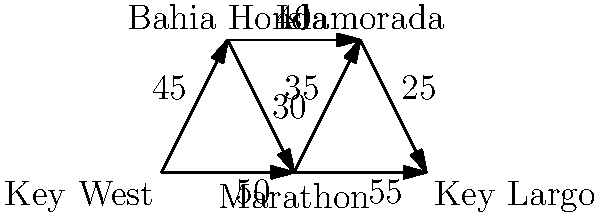As a new resident in the Florida Keys, you want to explore the popular tourist attractions. The graph shows the distances (in miles) between key locations. What is the shortest path from Key West to Key Largo, and what is its total distance? To find the shortest path from Key West to Key Largo, we'll use Dijkstra's algorithm:

1. Start at Key West (source node).
2. Initialize distances: Key West (0), others (infinity).
3. Visit unvisited node with smallest distance (Key West).
4. Update distances to neighbors:
   - Bahia Honda: 45 miles
   - Marathon: 50 miles
5. Visit Marathon (50 < 45).
6. Update distances:
   - Bahia Honda: min(45, 50 + 30) = 45 miles
   - Islamorada: 50 + 35 = 85 miles
   - Key Largo: 50 + 55 = 105 miles
7. Visit Bahia Honda (45 < 85).
8. Update distances:
   - Islamorada: min(85, 45 + 40) = 85 miles
9. Visit Islamorada (85 < 105).
10. Update distances:
    - Key Largo: min(105, 85 + 25) = 85 + 25 = 110 miles

The shortest path is Key West → Marathon → Islamorada → Key Largo.
Total distance: 50 + 35 + 25 = 110 miles.
Answer: Key West → Marathon → Islamorada → Key Largo; 110 miles 